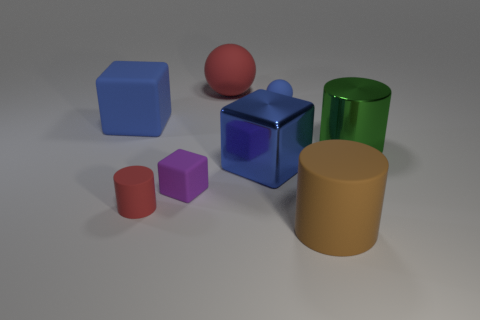What number of objects are either spheres or large blue matte blocks?
Offer a terse response. 3. Is the small block made of the same material as the large blue object that is right of the large red rubber ball?
Offer a terse response. No. There is a green metallic object right of the red sphere; how big is it?
Your response must be concise. Large. Are there fewer large blue cubes than tiny blue cylinders?
Keep it short and to the point. No. Is there a matte block that has the same color as the metal cube?
Your response must be concise. Yes. There is a thing that is both to the right of the small ball and left of the green thing; what is its shape?
Offer a terse response. Cylinder. There is a large blue thing on the right side of the blue object to the left of the large rubber ball; what shape is it?
Your answer should be compact. Cube. Does the brown object have the same shape as the tiny purple rubber thing?
Ensure brevity in your answer.  No. What is the material of the big object that is the same color as the shiny cube?
Your response must be concise. Rubber. Is the big shiny block the same color as the large rubber cube?
Your answer should be very brief. Yes. 